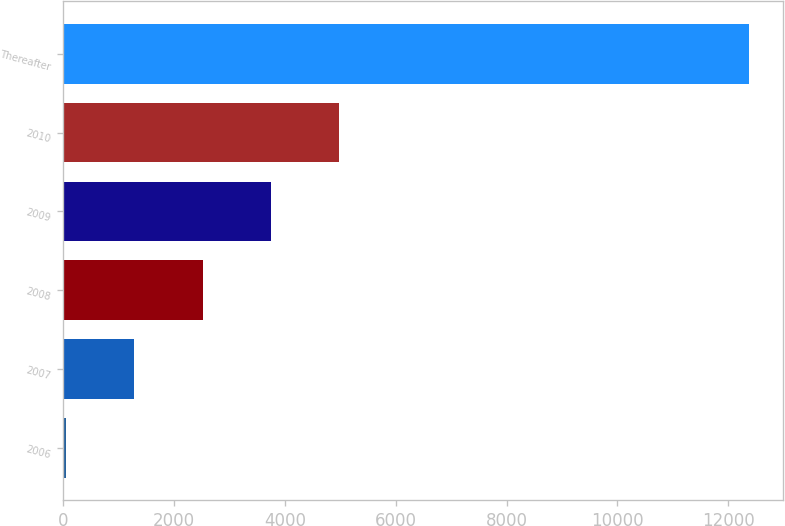Convert chart. <chart><loc_0><loc_0><loc_500><loc_500><bar_chart><fcel>2006<fcel>2007<fcel>2008<fcel>2009<fcel>2010<fcel>Thereafter<nl><fcel>50<fcel>1282.6<fcel>2515.2<fcel>3747.8<fcel>4980.4<fcel>12376<nl></chart> 